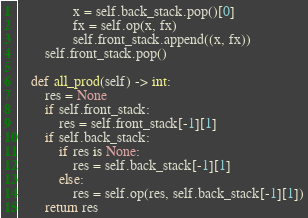<code> <loc_0><loc_0><loc_500><loc_500><_Python_>				x = self.back_stack.pop()[0]
				fx = self.op(x, fx)
				self.front_stack.append((x, fx))
		self.front_stack.pop()

	def all_prod(self) -> int:
		res = None
		if self.front_stack:
			res = self.front_stack[-1][1]
		if self.back_stack:
			if res is None:
				res = self.back_stack[-1][1]
			else:
				res = self.op(res, self.back_stack[-1][1])
		return res
</code> 